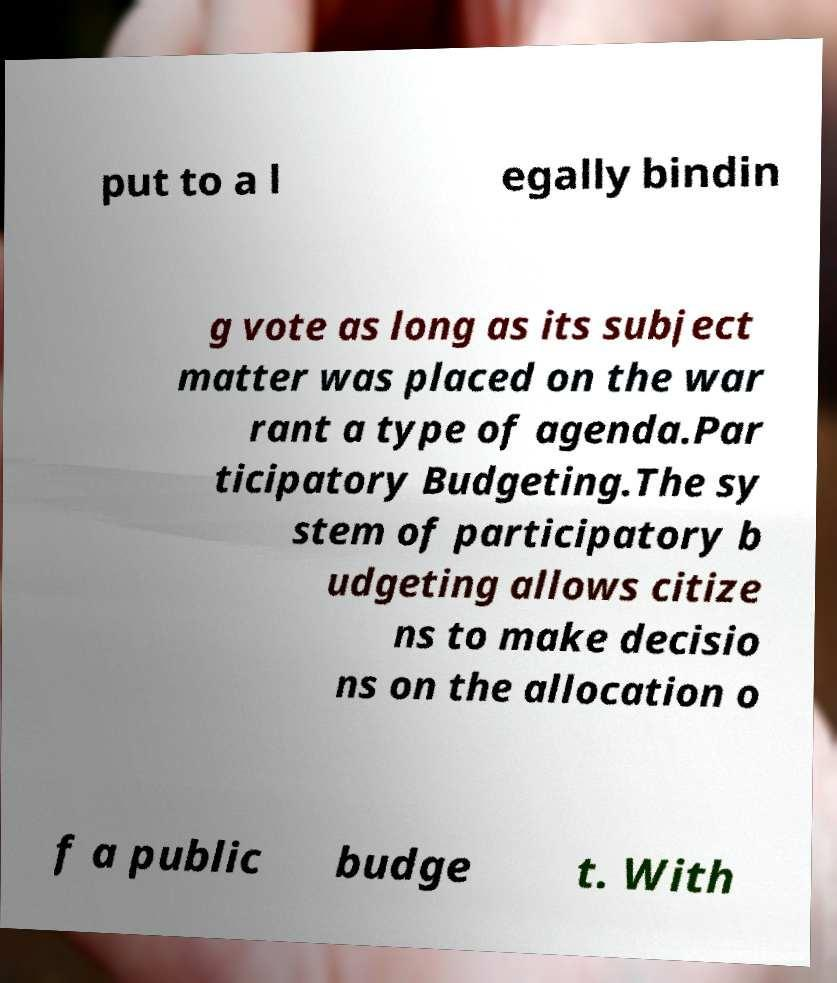For documentation purposes, I need the text within this image transcribed. Could you provide that? put to a l egally bindin g vote as long as its subject matter was placed on the war rant a type of agenda.Par ticipatory Budgeting.The sy stem of participatory b udgeting allows citize ns to make decisio ns on the allocation o f a public budge t. With 